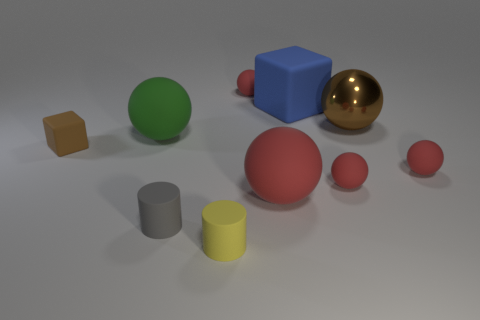Subtract all red balls. How many were subtracted if there are1red balls left? 3 Subtract all big metallic spheres. How many spheres are left? 5 Subtract all gray cylinders. How many cylinders are left? 1 Subtract 2 cylinders. How many cylinders are left? 0 Subtract 1 brown spheres. How many objects are left? 9 Subtract all spheres. How many objects are left? 4 Subtract all blue blocks. Subtract all cyan cylinders. How many blocks are left? 1 Subtract all brown cubes. How many green balls are left? 1 Subtract all big purple metal blocks. Subtract all small gray cylinders. How many objects are left? 9 Add 6 big red spheres. How many big red spheres are left? 7 